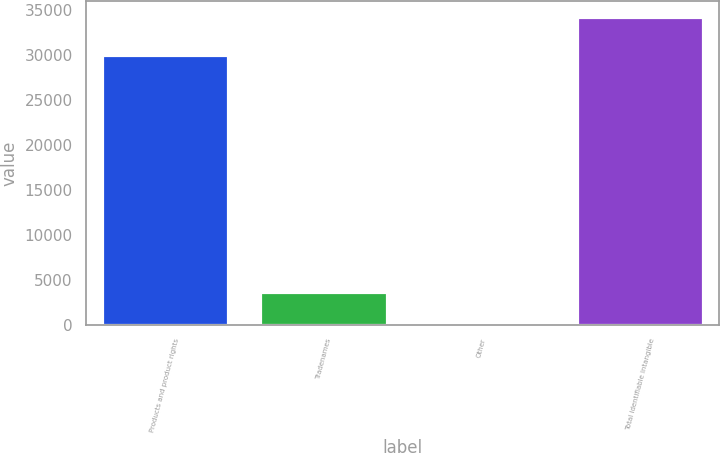Convert chart. <chart><loc_0><loc_0><loc_500><loc_500><bar_chart><fcel>Products and product rights<fcel>Tradenames<fcel>Other<fcel>Total identifiable intangible<nl><fcel>30065<fcel>3621.9<fcel>213<fcel>34302<nl></chart> 